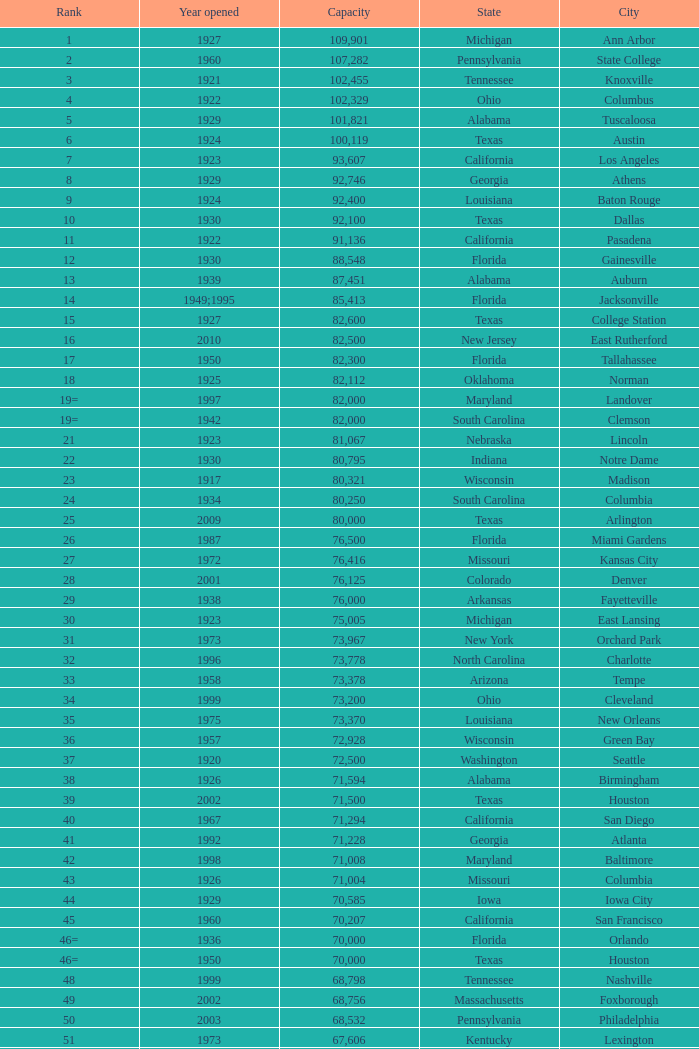What is the lowest capacity for 1903? 30323.0. 